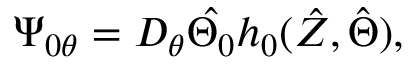Convert formula to latex. <formula><loc_0><loc_0><loc_500><loc_500>\Psi _ { 0 \theta } = D _ { \theta } \hat { \Theta _ { 0 } } h _ { 0 } ( \hat { Z } , \hat { \Theta } ) ,</formula> 